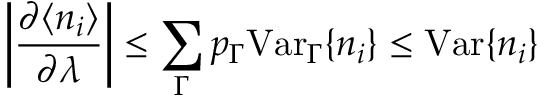<formula> <loc_0><loc_0><loc_500><loc_500>\left | \frac { \partial \langle n _ { i } \rangle } { \partial \lambda } \right | \leq \sum _ { \Gamma } p _ { \Gamma } V a r _ { \Gamma } \{ n _ { i } \} \leq V a r \{ n _ { i } \}</formula> 